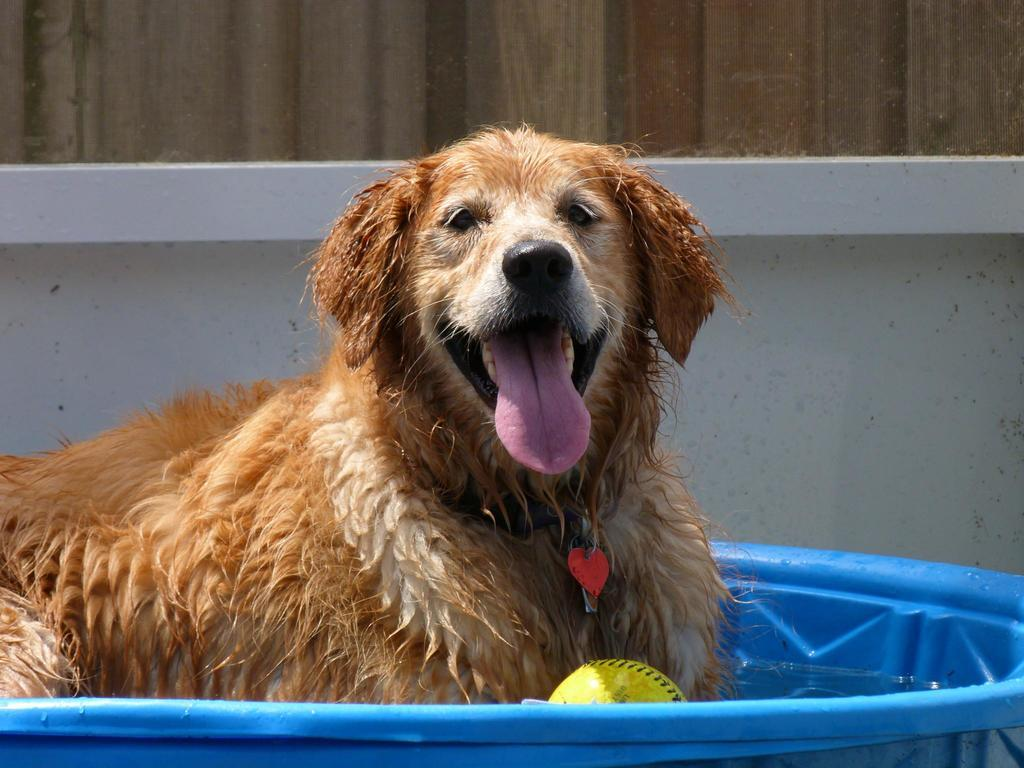What animal can be seen in the image? There is a dog in the image. Can you describe the color of the dog? The dog is white and pale brown in color. Where is the dog located in the image? The dog is sitting in a water tub. What other object is present in the image? There is a ball in the image. What can be seen in the background of the image? There is a wall in the image. Reasoning: Let'ing: Let's think step by step in order to produce the conversation. We start by identifying the main subject in the image, which is the dog. Then, we describe the dog's color and location, which are also provided in the facts. Next, we mention the presence of the ball, which is another object in the image. Finally, we describe the background by mentioning the wall. Each question is designed to elicit a specific detail about the image that is known from the provided facts. Absurd Question/Answer: What type of books can be found in the library depicted in the image? There is no library present in the image; it features a dog sitting in a water tub. 